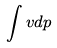Convert formula to latex. <formula><loc_0><loc_0><loc_500><loc_500>\int v d p</formula> 